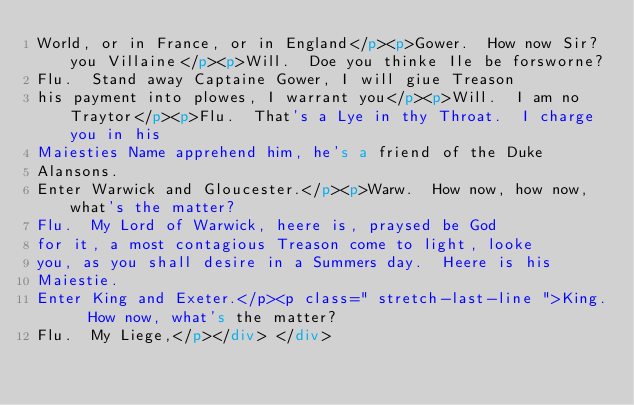Convert code to text. <code><loc_0><loc_0><loc_500><loc_500><_HTML_>World, or in France, or in England</p><p>Gower.  How now Sir? you Villaine</p><p>Will.  Doe you thinke Ile be forsworne?
Flu.  Stand away Captaine Gower, I will giue Treason
his payment into plowes, I warrant you</p><p>Will.  I am no Traytor</p><p>Flu.  That's a Lye in thy Throat.  I charge you in his
Maiesties Name apprehend him, he's a friend of the Duke
Alansons. 
Enter Warwick and Gloucester.</p><p>Warw.  How now, how now, what's the matter?
Flu.  My Lord of Warwick, heere is, praysed be God
for it, a most contagious Treason come to light, looke
you, as you shall desire in a Summers day.  Heere is his
Maiestie. 
Enter King and Exeter.</p><p class=" stretch-last-line ">King.  How now, what's the matter?
Flu.  My Liege,</p></div> </div></code> 